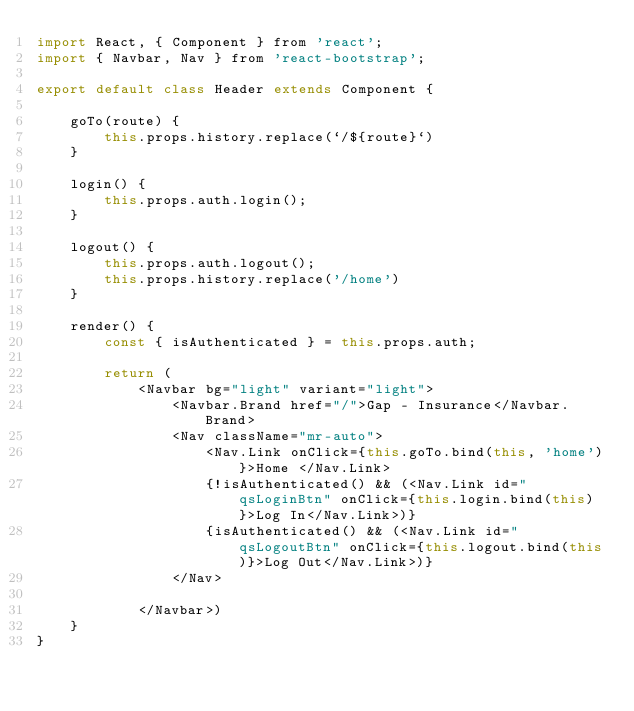<code> <loc_0><loc_0><loc_500><loc_500><_JavaScript_>import React, { Component } from 'react';
import { Navbar, Nav } from 'react-bootstrap';

export default class Header extends Component {

    goTo(route) {
        this.props.history.replace(`/${route}`)
    }

    login() {
        this.props.auth.login();
    }

    logout() {
        this.props.auth.logout();
        this.props.history.replace('/home')
    }

    render() {
        const { isAuthenticated } = this.props.auth;

        return (
            <Navbar bg="light" variant="light">
                <Navbar.Brand href="/">Gap - Insurance</Navbar.Brand>
                <Nav className="mr-auto">
                    <Nav.Link onClick={this.goTo.bind(this, 'home')}>Home </Nav.Link>
                    {!isAuthenticated() && (<Nav.Link id="qsLoginBtn" onClick={this.login.bind(this)}>Log In</Nav.Link>)}
                    {isAuthenticated() && (<Nav.Link id="qsLogoutBtn" onClick={this.logout.bind(this)}>Log Out</Nav.Link>)}
                </Nav>

            </Navbar>)
    }
}</code> 